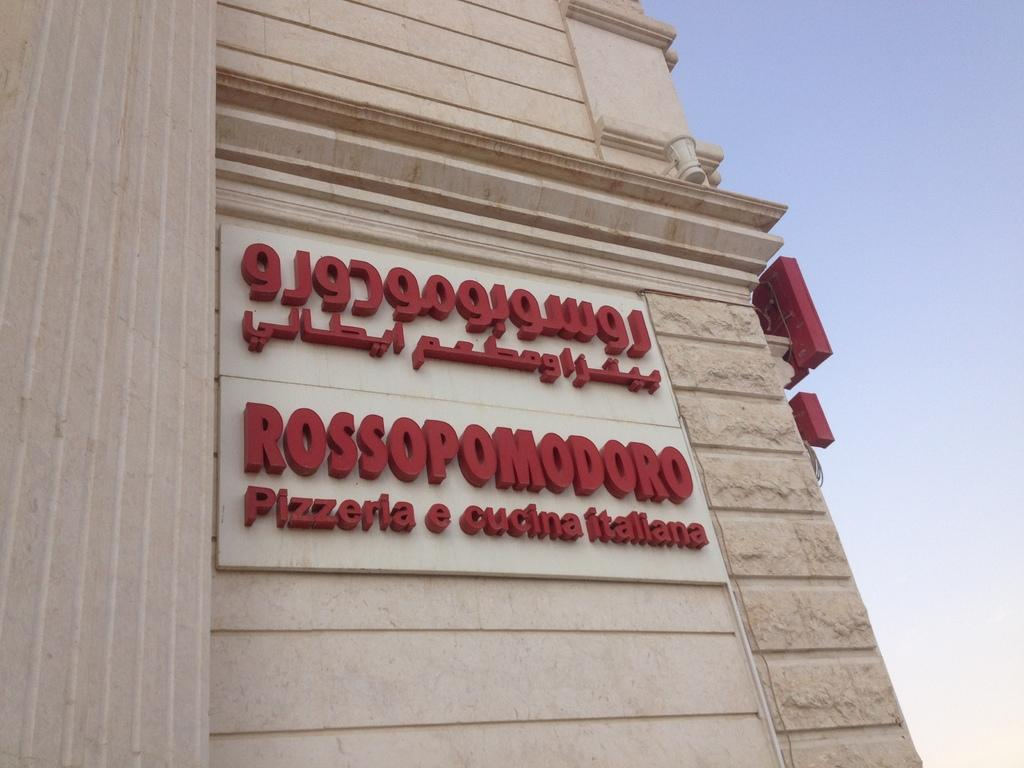What type of structure is present in the image? There is a building in the image. What can be seen on the wall of the building? There are boards on the wall in the image. What is written or displayed on the boards? The boards on the wall have text on them. What is the color of the sky in the image? The sky is blue in the image. How many people are folding clothes in the image? There is no indication of people folding clothes in the image. Is there a jail visible in the image? There is no jail present in the image. Where can you find a pocket in the image? There is no pocket visible in the image. 